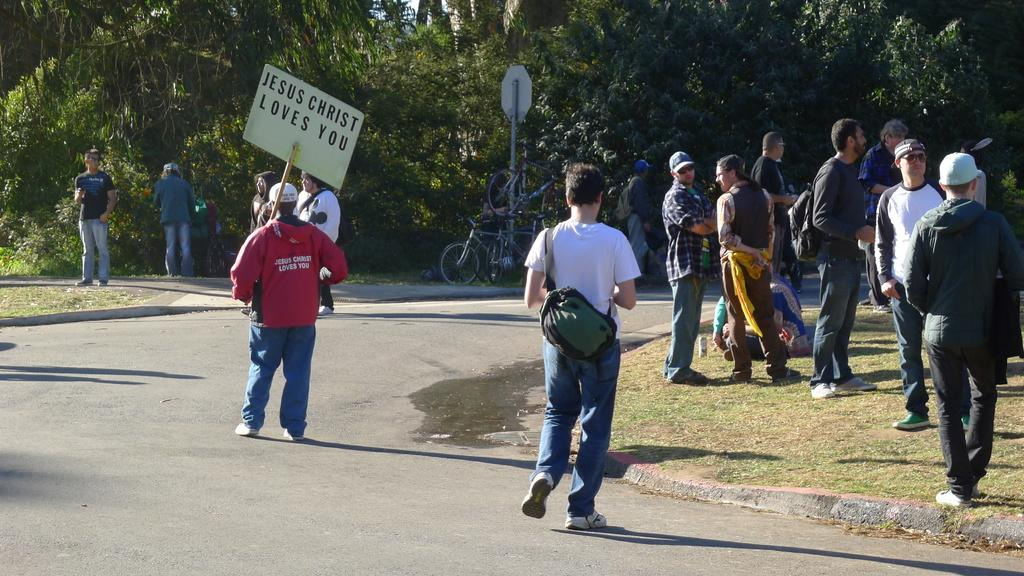What are the people in the image doing? The people in the image are standing and walking. What are the people holding in the image? The people are holding banners and bags. What can be seen in the background of the image? There are trees, bicycles, poles, and sign boards visible in the background. What type of ray is visible on the ground in the image? There is no ray visible on the ground in the image. 